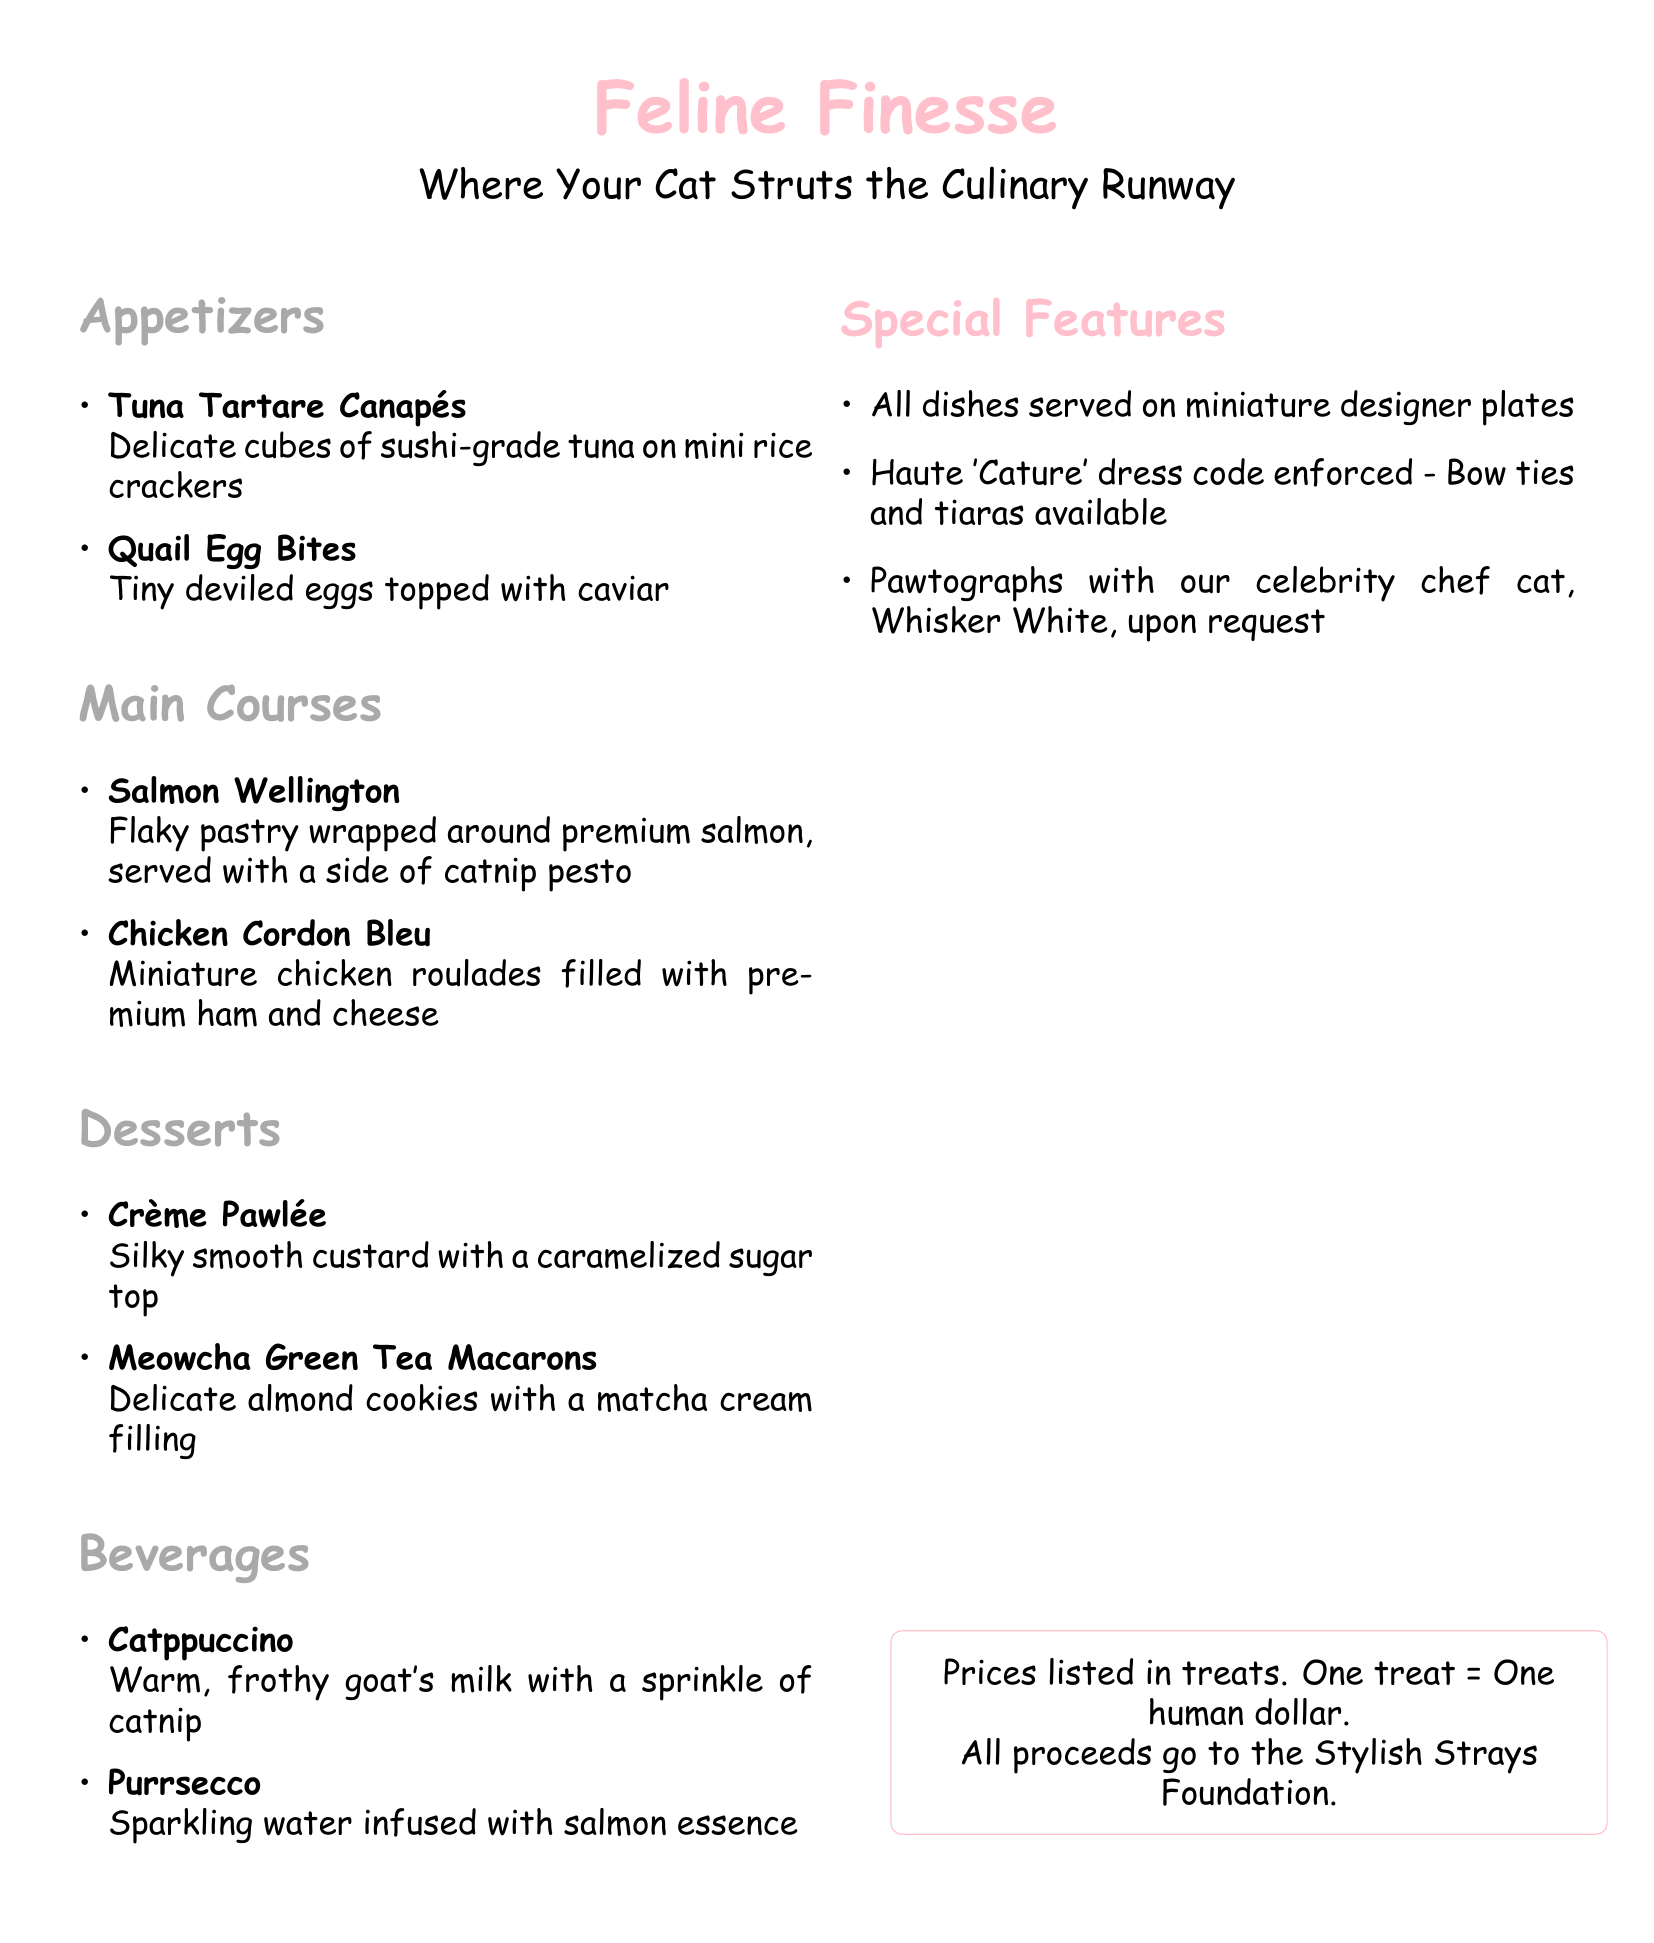What are the appetizers listed? The appetizers include two items: Tuna Tartare Canapés and Quail Egg Bites.
Answer: Tuna Tartare Canapés, Quail Egg Bites What is the main ingredient in the Salmon Wellington? The Salmon Wellington is primarily made of premium salmon.
Answer: Premium salmon How many desserts are offered in the menu? The menu lists two desserts: Crème Pawlée and Meowcha Green Tea Macarons.
Answer: Two What is the beverage that features goat's milk? The beverage that includes goat's milk is called Catppuccino.
Answer: Catppuccino What unique culinary feature is mentioned in the special features section? The special features section mentions that all dishes are served on miniature designer plates.
Answer: Miniature designer plates Which dish is described as having caviar? The appetizer that is topped with caviar is called Quail Egg Bites.
Answer: Quail Egg Bites What dress code is enforced at the restaurant? The dress code enforced is called Haute 'Cature.'
Answer: Haute 'Cature' Who is the celebrity chef cat at the restaurant? The celebrity chef cat mentioned in the document is Whisker White.
Answer: Whisker White 